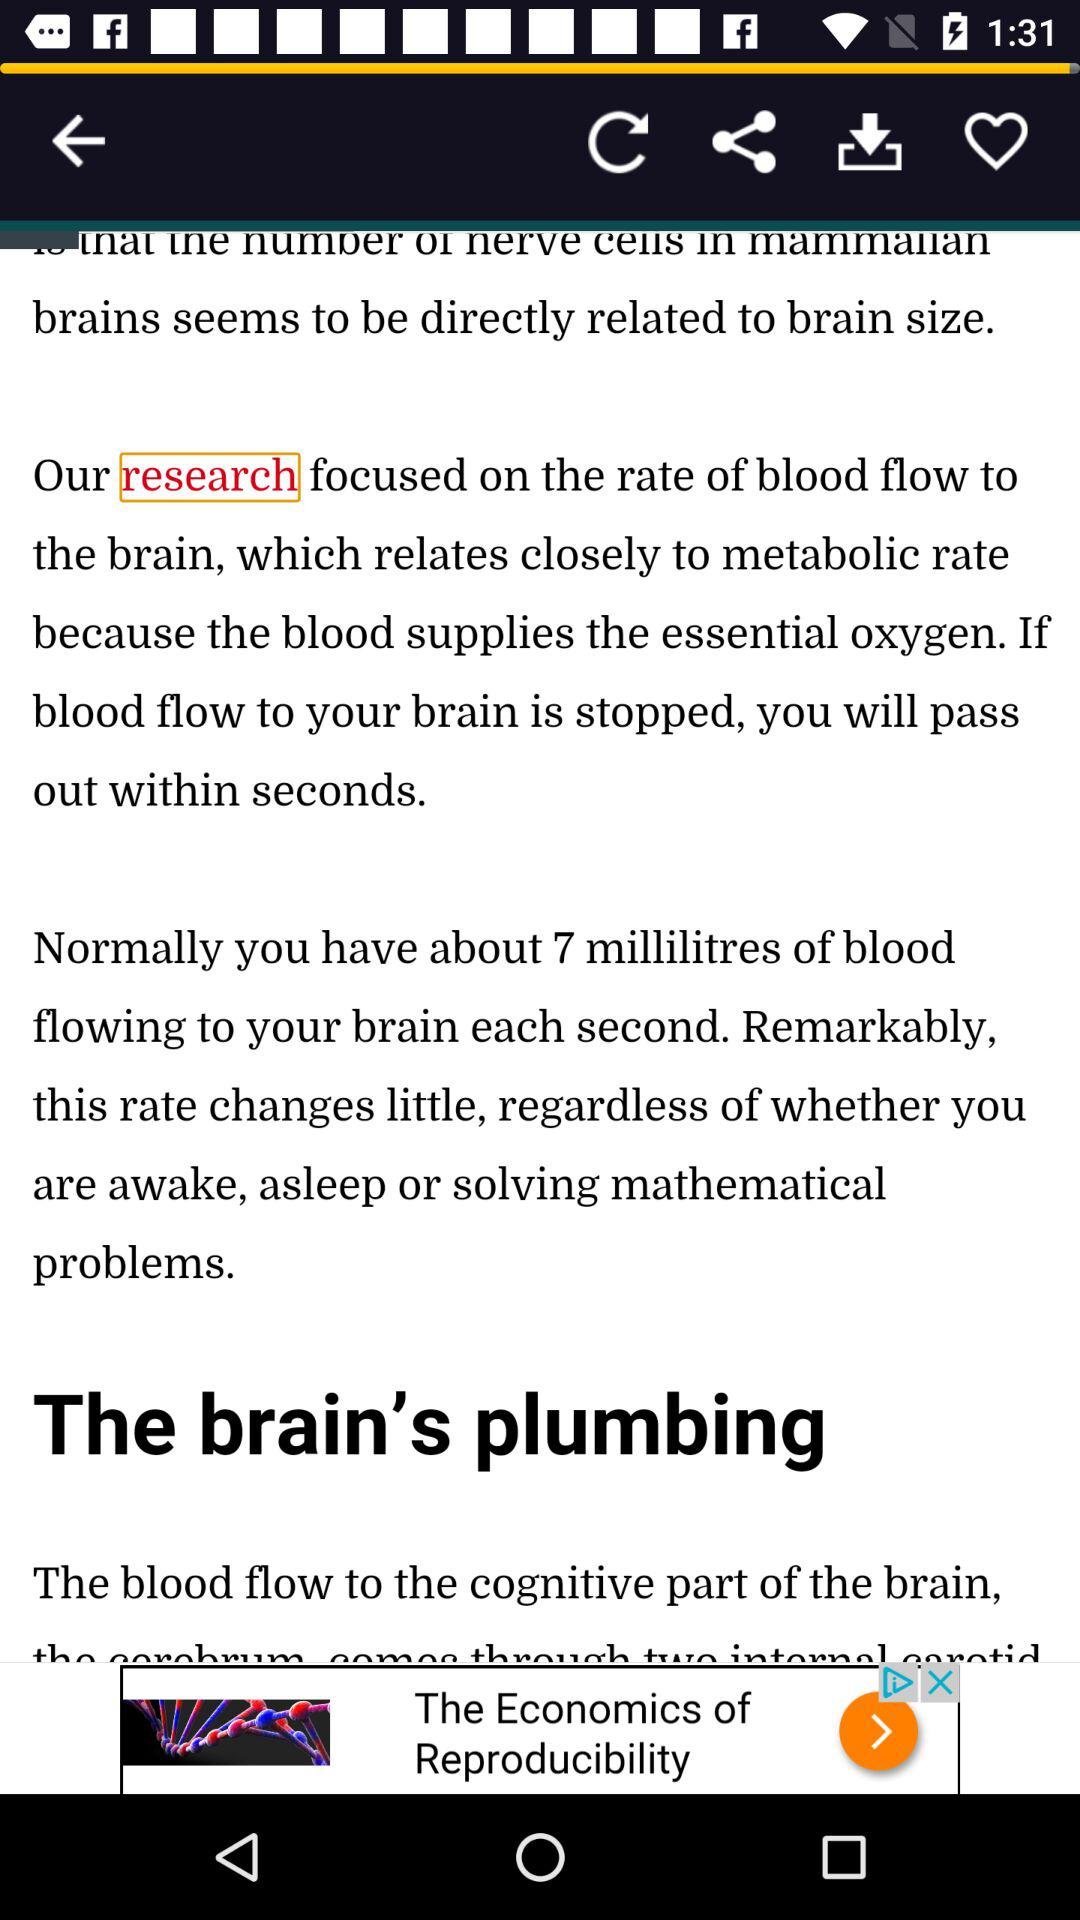How many millilitres of blood flow to the brain each second when awake, asleep, or solving mathematical problems?
Answer the question using a single word or phrase. 7 